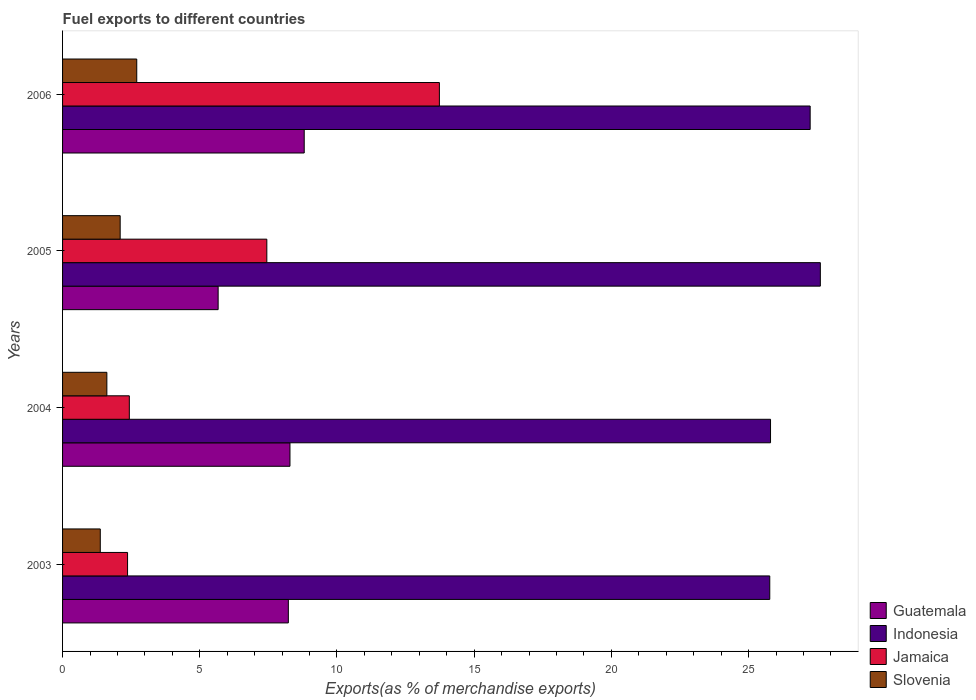How many different coloured bars are there?
Ensure brevity in your answer.  4. How many groups of bars are there?
Provide a succinct answer. 4. How many bars are there on the 2nd tick from the bottom?
Make the answer very short. 4. In how many cases, is the number of bars for a given year not equal to the number of legend labels?
Offer a very short reply. 0. What is the percentage of exports to different countries in Guatemala in 2003?
Provide a succinct answer. 8.23. Across all years, what is the maximum percentage of exports to different countries in Jamaica?
Provide a succinct answer. 13.73. Across all years, what is the minimum percentage of exports to different countries in Slovenia?
Ensure brevity in your answer.  1.37. What is the total percentage of exports to different countries in Guatemala in the graph?
Provide a succinct answer. 30.99. What is the difference between the percentage of exports to different countries in Slovenia in 2003 and that in 2004?
Ensure brevity in your answer.  -0.24. What is the difference between the percentage of exports to different countries in Slovenia in 2005 and the percentage of exports to different countries in Guatemala in 2003?
Keep it short and to the point. -6.13. What is the average percentage of exports to different countries in Guatemala per year?
Make the answer very short. 7.75. In the year 2006, what is the difference between the percentage of exports to different countries in Indonesia and percentage of exports to different countries in Guatemala?
Provide a succinct answer. 18.44. What is the ratio of the percentage of exports to different countries in Guatemala in 2004 to that in 2005?
Offer a terse response. 1.46. Is the percentage of exports to different countries in Jamaica in 2004 less than that in 2006?
Your response must be concise. Yes. Is the difference between the percentage of exports to different countries in Indonesia in 2004 and 2005 greater than the difference between the percentage of exports to different countries in Guatemala in 2004 and 2005?
Provide a short and direct response. No. What is the difference between the highest and the second highest percentage of exports to different countries in Indonesia?
Your response must be concise. 0.37. What is the difference between the highest and the lowest percentage of exports to different countries in Jamaica?
Keep it short and to the point. 11.36. In how many years, is the percentage of exports to different countries in Indonesia greater than the average percentage of exports to different countries in Indonesia taken over all years?
Offer a very short reply. 2. Is it the case that in every year, the sum of the percentage of exports to different countries in Slovenia and percentage of exports to different countries in Indonesia is greater than the sum of percentage of exports to different countries in Guatemala and percentage of exports to different countries in Jamaica?
Ensure brevity in your answer.  Yes. What does the 4th bar from the top in 2005 represents?
Your answer should be very brief. Guatemala. What does the 3rd bar from the bottom in 2004 represents?
Ensure brevity in your answer.  Jamaica. How many bars are there?
Your response must be concise. 16. How many years are there in the graph?
Your answer should be very brief. 4. Where does the legend appear in the graph?
Ensure brevity in your answer.  Bottom right. How are the legend labels stacked?
Ensure brevity in your answer.  Vertical. What is the title of the graph?
Your answer should be compact. Fuel exports to different countries. Does "St. Kitts and Nevis" appear as one of the legend labels in the graph?
Offer a terse response. No. What is the label or title of the X-axis?
Give a very brief answer. Exports(as % of merchandise exports). What is the Exports(as % of merchandise exports) in Guatemala in 2003?
Keep it short and to the point. 8.23. What is the Exports(as % of merchandise exports) in Indonesia in 2003?
Keep it short and to the point. 25.77. What is the Exports(as % of merchandise exports) of Jamaica in 2003?
Offer a terse response. 2.37. What is the Exports(as % of merchandise exports) of Slovenia in 2003?
Your answer should be compact. 1.37. What is the Exports(as % of merchandise exports) of Guatemala in 2004?
Provide a short and direct response. 8.29. What is the Exports(as % of merchandise exports) in Indonesia in 2004?
Your answer should be compact. 25.8. What is the Exports(as % of merchandise exports) of Jamaica in 2004?
Give a very brief answer. 2.43. What is the Exports(as % of merchandise exports) in Slovenia in 2004?
Provide a succinct answer. 1.61. What is the Exports(as % of merchandise exports) in Guatemala in 2005?
Keep it short and to the point. 5.67. What is the Exports(as % of merchandise exports) of Indonesia in 2005?
Provide a succinct answer. 27.61. What is the Exports(as % of merchandise exports) of Jamaica in 2005?
Give a very brief answer. 7.44. What is the Exports(as % of merchandise exports) in Slovenia in 2005?
Make the answer very short. 2.1. What is the Exports(as % of merchandise exports) of Guatemala in 2006?
Offer a terse response. 8.81. What is the Exports(as % of merchandise exports) in Indonesia in 2006?
Keep it short and to the point. 27.24. What is the Exports(as % of merchandise exports) in Jamaica in 2006?
Make the answer very short. 13.73. What is the Exports(as % of merchandise exports) of Slovenia in 2006?
Offer a terse response. 2.7. Across all years, what is the maximum Exports(as % of merchandise exports) in Guatemala?
Offer a very short reply. 8.81. Across all years, what is the maximum Exports(as % of merchandise exports) of Indonesia?
Your answer should be very brief. 27.61. Across all years, what is the maximum Exports(as % of merchandise exports) of Jamaica?
Offer a very short reply. 13.73. Across all years, what is the maximum Exports(as % of merchandise exports) of Slovenia?
Your response must be concise. 2.7. Across all years, what is the minimum Exports(as % of merchandise exports) of Guatemala?
Provide a short and direct response. 5.67. Across all years, what is the minimum Exports(as % of merchandise exports) of Indonesia?
Ensure brevity in your answer.  25.77. Across all years, what is the minimum Exports(as % of merchandise exports) of Jamaica?
Keep it short and to the point. 2.37. Across all years, what is the minimum Exports(as % of merchandise exports) in Slovenia?
Your response must be concise. 1.37. What is the total Exports(as % of merchandise exports) of Guatemala in the graph?
Keep it short and to the point. 30.99. What is the total Exports(as % of merchandise exports) in Indonesia in the graph?
Your response must be concise. 106.43. What is the total Exports(as % of merchandise exports) in Jamaica in the graph?
Make the answer very short. 25.98. What is the total Exports(as % of merchandise exports) of Slovenia in the graph?
Your answer should be compact. 7.79. What is the difference between the Exports(as % of merchandise exports) of Guatemala in 2003 and that in 2004?
Ensure brevity in your answer.  -0.06. What is the difference between the Exports(as % of merchandise exports) of Indonesia in 2003 and that in 2004?
Your answer should be very brief. -0.03. What is the difference between the Exports(as % of merchandise exports) of Jamaica in 2003 and that in 2004?
Make the answer very short. -0.06. What is the difference between the Exports(as % of merchandise exports) in Slovenia in 2003 and that in 2004?
Ensure brevity in your answer.  -0.24. What is the difference between the Exports(as % of merchandise exports) of Guatemala in 2003 and that in 2005?
Ensure brevity in your answer.  2.56. What is the difference between the Exports(as % of merchandise exports) in Indonesia in 2003 and that in 2005?
Keep it short and to the point. -1.84. What is the difference between the Exports(as % of merchandise exports) of Jamaica in 2003 and that in 2005?
Provide a short and direct response. -5.08. What is the difference between the Exports(as % of merchandise exports) of Slovenia in 2003 and that in 2005?
Offer a very short reply. -0.72. What is the difference between the Exports(as % of merchandise exports) of Guatemala in 2003 and that in 2006?
Your answer should be compact. -0.58. What is the difference between the Exports(as % of merchandise exports) of Indonesia in 2003 and that in 2006?
Make the answer very short. -1.47. What is the difference between the Exports(as % of merchandise exports) of Jamaica in 2003 and that in 2006?
Keep it short and to the point. -11.36. What is the difference between the Exports(as % of merchandise exports) in Slovenia in 2003 and that in 2006?
Offer a very short reply. -1.33. What is the difference between the Exports(as % of merchandise exports) in Guatemala in 2004 and that in 2005?
Your answer should be compact. 2.62. What is the difference between the Exports(as % of merchandise exports) in Indonesia in 2004 and that in 2005?
Provide a succinct answer. -1.81. What is the difference between the Exports(as % of merchandise exports) of Jamaica in 2004 and that in 2005?
Your answer should be compact. -5.01. What is the difference between the Exports(as % of merchandise exports) in Slovenia in 2004 and that in 2005?
Offer a very short reply. -0.48. What is the difference between the Exports(as % of merchandise exports) of Guatemala in 2004 and that in 2006?
Your answer should be very brief. -0.52. What is the difference between the Exports(as % of merchandise exports) of Indonesia in 2004 and that in 2006?
Give a very brief answer. -1.44. What is the difference between the Exports(as % of merchandise exports) in Jamaica in 2004 and that in 2006?
Your response must be concise. -11.3. What is the difference between the Exports(as % of merchandise exports) of Slovenia in 2004 and that in 2006?
Your response must be concise. -1.09. What is the difference between the Exports(as % of merchandise exports) of Guatemala in 2005 and that in 2006?
Offer a very short reply. -3.14. What is the difference between the Exports(as % of merchandise exports) in Indonesia in 2005 and that in 2006?
Your answer should be very brief. 0.37. What is the difference between the Exports(as % of merchandise exports) in Jamaica in 2005 and that in 2006?
Offer a very short reply. -6.29. What is the difference between the Exports(as % of merchandise exports) of Slovenia in 2005 and that in 2006?
Ensure brevity in your answer.  -0.6. What is the difference between the Exports(as % of merchandise exports) in Guatemala in 2003 and the Exports(as % of merchandise exports) in Indonesia in 2004?
Give a very brief answer. -17.57. What is the difference between the Exports(as % of merchandise exports) of Guatemala in 2003 and the Exports(as % of merchandise exports) of Jamaica in 2004?
Provide a short and direct response. 5.79. What is the difference between the Exports(as % of merchandise exports) in Guatemala in 2003 and the Exports(as % of merchandise exports) in Slovenia in 2004?
Keep it short and to the point. 6.61. What is the difference between the Exports(as % of merchandise exports) in Indonesia in 2003 and the Exports(as % of merchandise exports) in Jamaica in 2004?
Offer a very short reply. 23.34. What is the difference between the Exports(as % of merchandise exports) in Indonesia in 2003 and the Exports(as % of merchandise exports) in Slovenia in 2004?
Your answer should be compact. 24.16. What is the difference between the Exports(as % of merchandise exports) in Jamaica in 2003 and the Exports(as % of merchandise exports) in Slovenia in 2004?
Provide a succinct answer. 0.75. What is the difference between the Exports(as % of merchandise exports) in Guatemala in 2003 and the Exports(as % of merchandise exports) in Indonesia in 2005?
Provide a succinct answer. -19.39. What is the difference between the Exports(as % of merchandise exports) of Guatemala in 2003 and the Exports(as % of merchandise exports) of Jamaica in 2005?
Make the answer very short. 0.78. What is the difference between the Exports(as % of merchandise exports) of Guatemala in 2003 and the Exports(as % of merchandise exports) of Slovenia in 2005?
Provide a succinct answer. 6.13. What is the difference between the Exports(as % of merchandise exports) of Indonesia in 2003 and the Exports(as % of merchandise exports) of Jamaica in 2005?
Provide a short and direct response. 18.33. What is the difference between the Exports(as % of merchandise exports) in Indonesia in 2003 and the Exports(as % of merchandise exports) in Slovenia in 2005?
Your answer should be compact. 23.67. What is the difference between the Exports(as % of merchandise exports) of Jamaica in 2003 and the Exports(as % of merchandise exports) of Slovenia in 2005?
Provide a short and direct response. 0.27. What is the difference between the Exports(as % of merchandise exports) of Guatemala in 2003 and the Exports(as % of merchandise exports) of Indonesia in 2006?
Your response must be concise. -19.02. What is the difference between the Exports(as % of merchandise exports) in Guatemala in 2003 and the Exports(as % of merchandise exports) in Jamaica in 2006?
Offer a terse response. -5.5. What is the difference between the Exports(as % of merchandise exports) of Guatemala in 2003 and the Exports(as % of merchandise exports) of Slovenia in 2006?
Offer a terse response. 5.52. What is the difference between the Exports(as % of merchandise exports) of Indonesia in 2003 and the Exports(as % of merchandise exports) of Jamaica in 2006?
Your answer should be compact. 12.04. What is the difference between the Exports(as % of merchandise exports) of Indonesia in 2003 and the Exports(as % of merchandise exports) of Slovenia in 2006?
Provide a short and direct response. 23.07. What is the difference between the Exports(as % of merchandise exports) of Jamaica in 2003 and the Exports(as % of merchandise exports) of Slovenia in 2006?
Ensure brevity in your answer.  -0.34. What is the difference between the Exports(as % of merchandise exports) of Guatemala in 2004 and the Exports(as % of merchandise exports) of Indonesia in 2005?
Make the answer very short. -19.33. What is the difference between the Exports(as % of merchandise exports) in Guatemala in 2004 and the Exports(as % of merchandise exports) in Jamaica in 2005?
Ensure brevity in your answer.  0.84. What is the difference between the Exports(as % of merchandise exports) in Guatemala in 2004 and the Exports(as % of merchandise exports) in Slovenia in 2005?
Give a very brief answer. 6.19. What is the difference between the Exports(as % of merchandise exports) of Indonesia in 2004 and the Exports(as % of merchandise exports) of Jamaica in 2005?
Provide a short and direct response. 18.36. What is the difference between the Exports(as % of merchandise exports) in Indonesia in 2004 and the Exports(as % of merchandise exports) in Slovenia in 2005?
Give a very brief answer. 23.7. What is the difference between the Exports(as % of merchandise exports) in Jamaica in 2004 and the Exports(as % of merchandise exports) in Slovenia in 2005?
Your answer should be very brief. 0.33. What is the difference between the Exports(as % of merchandise exports) in Guatemala in 2004 and the Exports(as % of merchandise exports) in Indonesia in 2006?
Ensure brevity in your answer.  -18.96. What is the difference between the Exports(as % of merchandise exports) of Guatemala in 2004 and the Exports(as % of merchandise exports) of Jamaica in 2006?
Keep it short and to the point. -5.45. What is the difference between the Exports(as % of merchandise exports) in Guatemala in 2004 and the Exports(as % of merchandise exports) in Slovenia in 2006?
Your answer should be compact. 5.58. What is the difference between the Exports(as % of merchandise exports) in Indonesia in 2004 and the Exports(as % of merchandise exports) in Jamaica in 2006?
Give a very brief answer. 12.07. What is the difference between the Exports(as % of merchandise exports) in Indonesia in 2004 and the Exports(as % of merchandise exports) in Slovenia in 2006?
Keep it short and to the point. 23.1. What is the difference between the Exports(as % of merchandise exports) in Jamaica in 2004 and the Exports(as % of merchandise exports) in Slovenia in 2006?
Keep it short and to the point. -0.27. What is the difference between the Exports(as % of merchandise exports) in Guatemala in 2005 and the Exports(as % of merchandise exports) in Indonesia in 2006?
Give a very brief answer. -21.57. What is the difference between the Exports(as % of merchandise exports) in Guatemala in 2005 and the Exports(as % of merchandise exports) in Jamaica in 2006?
Your answer should be compact. -8.06. What is the difference between the Exports(as % of merchandise exports) in Guatemala in 2005 and the Exports(as % of merchandise exports) in Slovenia in 2006?
Keep it short and to the point. 2.97. What is the difference between the Exports(as % of merchandise exports) of Indonesia in 2005 and the Exports(as % of merchandise exports) of Jamaica in 2006?
Offer a terse response. 13.88. What is the difference between the Exports(as % of merchandise exports) in Indonesia in 2005 and the Exports(as % of merchandise exports) in Slovenia in 2006?
Offer a terse response. 24.91. What is the difference between the Exports(as % of merchandise exports) in Jamaica in 2005 and the Exports(as % of merchandise exports) in Slovenia in 2006?
Your answer should be very brief. 4.74. What is the average Exports(as % of merchandise exports) in Guatemala per year?
Provide a succinct answer. 7.75. What is the average Exports(as % of merchandise exports) of Indonesia per year?
Make the answer very short. 26.61. What is the average Exports(as % of merchandise exports) of Jamaica per year?
Make the answer very short. 6.49. What is the average Exports(as % of merchandise exports) of Slovenia per year?
Your answer should be very brief. 1.95. In the year 2003, what is the difference between the Exports(as % of merchandise exports) of Guatemala and Exports(as % of merchandise exports) of Indonesia?
Provide a succinct answer. -17.54. In the year 2003, what is the difference between the Exports(as % of merchandise exports) of Guatemala and Exports(as % of merchandise exports) of Jamaica?
Ensure brevity in your answer.  5.86. In the year 2003, what is the difference between the Exports(as % of merchandise exports) in Guatemala and Exports(as % of merchandise exports) in Slovenia?
Make the answer very short. 6.85. In the year 2003, what is the difference between the Exports(as % of merchandise exports) of Indonesia and Exports(as % of merchandise exports) of Jamaica?
Your response must be concise. 23.4. In the year 2003, what is the difference between the Exports(as % of merchandise exports) of Indonesia and Exports(as % of merchandise exports) of Slovenia?
Give a very brief answer. 24.4. In the year 2003, what is the difference between the Exports(as % of merchandise exports) of Jamaica and Exports(as % of merchandise exports) of Slovenia?
Ensure brevity in your answer.  0.99. In the year 2004, what is the difference between the Exports(as % of merchandise exports) in Guatemala and Exports(as % of merchandise exports) in Indonesia?
Your answer should be compact. -17.51. In the year 2004, what is the difference between the Exports(as % of merchandise exports) of Guatemala and Exports(as % of merchandise exports) of Jamaica?
Keep it short and to the point. 5.85. In the year 2004, what is the difference between the Exports(as % of merchandise exports) in Guatemala and Exports(as % of merchandise exports) in Slovenia?
Your answer should be compact. 6.67. In the year 2004, what is the difference between the Exports(as % of merchandise exports) of Indonesia and Exports(as % of merchandise exports) of Jamaica?
Your answer should be very brief. 23.37. In the year 2004, what is the difference between the Exports(as % of merchandise exports) in Indonesia and Exports(as % of merchandise exports) in Slovenia?
Give a very brief answer. 24.19. In the year 2004, what is the difference between the Exports(as % of merchandise exports) in Jamaica and Exports(as % of merchandise exports) in Slovenia?
Ensure brevity in your answer.  0.82. In the year 2005, what is the difference between the Exports(as % of merchandise exports) of Guatemala and Exports(as % of merchandise exports) of Indonesia?
Keep it short and to the point. -21.95. In the year 2005, what is the difference between the Exports(as % of merchandise exports) of Guatemala and Exports(as % of merchandise exports) of Jamaica?
Keep it short and to the point. -1.77. In the year 2005, what is the difference between the Exports(as % of merchandise exports) of Guatemala and Exports(as % of merchandise exports) of Slovenia?
Make the answer very short. 3.57. In the year 2005, what is the difference between the Exports(as % of merchandise exports) of Indonesia and Exports(as % of merchandise exports) of Jamaica?
Provide a succinct answer. 20.17. In the year 2005, what is the difference between the Exports(as % of merchandise exports) of Indonesia and Exports(as % of merchandise exports) of Slovenia?
Offer a terse response. 25.52. In the year 2005, what is the difference between the Exports(as % of merchandise exports) of Jamaica and Exports(as % of merchandise exports) of Slovenia?
Provide a succinct answer. 5.34. In the year 2006, what is the difference between the Exports(as % of merchandise exports) of Guatemala and Exports(as % of merchandise exports) of Indonesia?
Ensure brevity in your answer.  -18.44. In the year 2006, what is the difference between the Exports(as % of merchandise exports) in Guatemala and Exports(as % of merchandise exports) in Jamaica?
Make the answer very short. -4.93. In the year 2006, what is the difference between the Exports(as % of merchandise exports) of Guatemala and Exports(as % of merchandise exports) of Slovenia?
Give a very brief answer. 6.1. In the year 2006, what is the difference between the Exports(as % of merchandise exports) in Indonesia and Exports(as % of merchandise exports) in Jamaica?
Offer a terse response. 13.51. In the year 2006, what is the difference between the Exports(as % of merchandise exports) in Indonesia and Exports(as % of merchandise exports) in Slovenia?
Your response must be concise. 24.54. In the year 2006, what is the difference between the Exports(as % of merchandise exports) in Jamaica and Exports(as % of merchandise exports) in Slovenia?
Offer a terse response. 11.03. What is the ratio of the Exports(as % of merchandise exports) of Guatemala in 2003 to that in 2004?
Provide a succinct answer. 0.99. What is the ratio of the Exports(as % of merchandise exports) in Indonesia in 2003 to that in 2004?
Your response must be concise. 1. What is the ratio of the Exports(as % of merchandise exports) of Jamaica in 2003 to that in 2004?
Provide a succinct answer. 0.97. What is the ratio of the Exports(as % of merchandise exports) of Slovenia in 2003 to that in 2004?
Your answer should be very brief. 0.85. What is the ratio of the Exports(as % of merchandise exports) of Guatemala in 2003 to that in 2005?
Give a very brief answer. 1.45. What is the ratio of the Exports(as % of merchandise exports) of Indonesia in 2003 to that in 2005?
Keep it short and to the point. 0.93. What is the ratio of the Exports(as % of merchandise exports) of Jamaica in 2003 to that in 2005?
Offer a terse response. 0.32. What is the ratio of the Exports(as % of merchandise exports) in Slovenia in 2003 to that in 2005?
Keep it short and to the point. 0.65. What is the ratio of the Exports(as % of merchandise exports) in Guatemala in 2003 to that in 2006?
Provide a short and direct response. 0.93. What is the ratio of the Exports(as % of merchandise exports) of Indonesia in 2003 to that in 2006?
Your answer should be very brief. 0.95. What is the ratio of the Exports(as % of merchandise exports) of Jamaica in 2003 to that in 2006?
Keep it short and to the point. 0.17. What is the ratio of the Exports(as % of merchandise exports) of Slovenia in 2003 to that in 2006?
Keep it short and to the point. 0.51. What is the ratio of the Exports(as % of merchandise exports) in Guatemala in 2004 to that in 2005?
Give a very brief answer. 1.46. What is the ratio of the Exports(as % of merchandise exports) of Indonesia in 2004 to that in 2005?
Offer a very short reply. 0.93. What is the ratio of the Exports(as % of merchandise exports) of Jamaica in 2004 to that in 2005?
Your answer should be very brief. 0.33. What is the ratio of the Exports(as % of merchandise exports) of Slovenia in 2004 to that in 2005?
Give a very brief answer. 0.77. What is the ratio of the Exports(as % of merchandise exports) in Guatemala in 2004 to that in 2006?
Your response must be concise. 0.94. What is the ratio of the Exports(as % of merchandise exports) in Indonesia in 2004 to that in 2006?
Your response must be concise. 0.95. What is the ratio of the Exports(as % of merchandise exports) in Jamaica in 2004 to that in 2006?
Provide a short and direct response. 0.18. What is the ratio of the Exports(as % of merchandise exports) in Slovenia in 2004 to that in 2006?
Ensure brevity in your answer.  0.6. What is the ratio of the Exports(as % of merchandise exports) in Guatemala in 2005 to that in 2006?
Ensure brevity in your answer.  0.64. What is the ratio of the Exports(as % of merchandise exports) in Indonesia in 2005 to that in 2006?
Make the answer very short. 1.01. What is the ratio of the Exports(as % of merchandise exports) in Jamaica in 2005 to that in 2006?
Ensure brevity in your answer.  0.54. What is the ratio of the Exports(as % of merchandise exports) in Slovenia in 2005 to that in 2006?
Your answer should be very brief. 0.78. What is the difference between the highest and the second highest Exports(as % of merchandise exports) of Guatemala?
Provide a short and direct response. 0.52. What is the difference between the highest and the second highest Exports(as % of merchandise exports) of Indonesia?
Ensure brevity in your answer.  0.37. What is the difference between the highest and the second highest Exports(as % of merchandise exports) in Jamaica?
Make the answer very short. 6.29. What is the difference between the highest and the second highest Exports(as % of merchandise exports) of Slovenia?
Your answer should be compact. 0.6. What is the difference between the highest and the lowest Exports(as % of merchandise exports) in Guatemala?
Ensure brevity in your answer.  3.14. What is the difference between the highest and the lowest Exports(as % of merchandise exports) in Indonesia?
Your answer should be very brief. 1.84. What is the difference between the highest and the lowest Exports(as % of merchandise exports) in Jamaica?
Your answer should be very brief. 11.36. What is the difference between the highest and the lowest Exports(as % of merchandise exports) of Slovenia?
Provide a short and direct response. 1.33. 